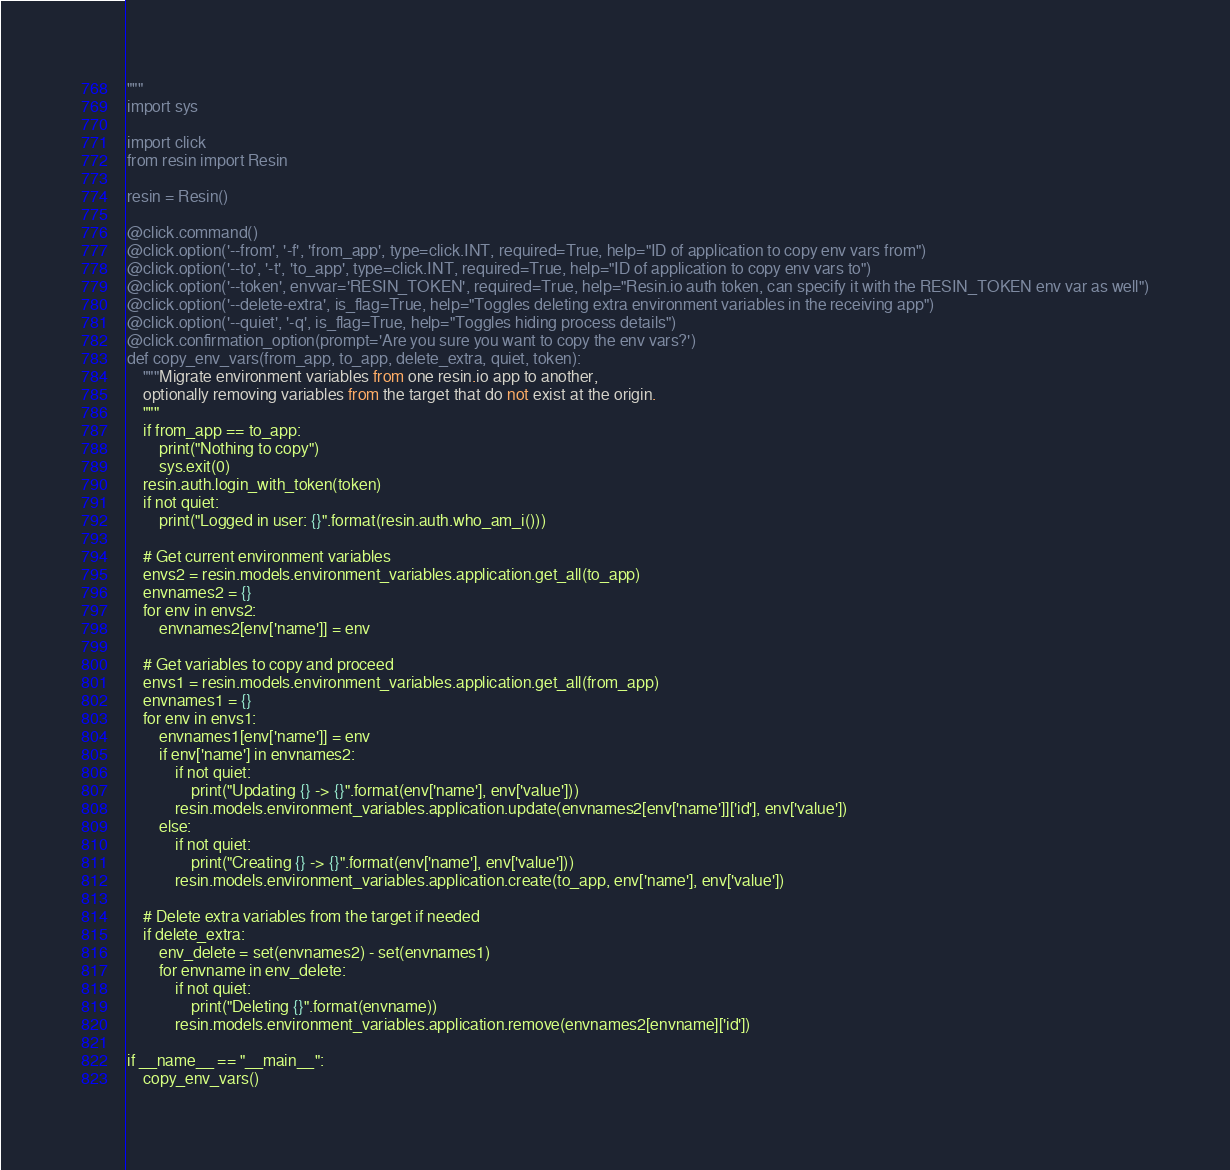<code> <loc_0><loc_0><loc_500><loc_500><_Python_>"""
import sys

import click
from resin import Resin

resin = Resin()

@click.command()
@click.option('--from', '-f', 'from_app', type=click.INT, required=True, help="ID of application to copy env vars from")
@click.option('--to', '-t', 'to_app', type=click.INT, required=True, help="ID of application to copy env vars to")
@click.option('--token', envvar='RESIN_TOKEN', required=True, help="Resin.io auth token, can specify it with the RESIN_TOKEN env var as well")
@click.option('--delete-extra', is_flag=True, help="Toggles deleting extra environment variables in the receiving app")
@click.option('--quiet', '-q', is_flag=True, help="Toggles hiding process details")
@click.confirmation_option(prompt='Are you sure you want to copy the env vars?')
def copy_env_vars(from_app, to_app, delete_extra, quiet, token):
    """Migrate environment variables from one resin.io app to another,
    optionally removing variables from the target that do not exist at the origin.
    """
    if from_app == to_app:
        print("Nothing to copy")
        sys.exit(0)
    resin.auth.login_with_token(token)
    if not quiet:
        print("Logged in user: {}".format(resin.auth.who_am_i()))

    # Get current environment variables
    envs2 = resin.models.environment_variables.application.get_all(to_app)
    envnames2 = {}
    for env in envs2:
        envnames2[env['name']] = env

    # Get variables to copy and proceed
    envs1 = resin.models.environment_variables.application.get_all(from_app)
    envnames1 = {}
    for env in envs1:
        envnames1[env['name']] = env
        if env['name'] in envnames2:
            if not quiet:
                print("Updating {} -> {}".format(env['name'], env['value']))
            resin.models.environment_variables.application.update(envnames2[env['name']]['id'], env['value'])
        else:
            if not quiet:
                print("Creating {} -> {}".format(env['name'], env['value']))
            resin.models.environment_variables.application.create(to_app, env['name'], env['value'])

    # Delete extra variables from the target if needed
    if delete_extra:
        env_delete = set(envnames2) - set(envnames1)
        for envname in env_delete:
            if not quiet:
                print("Deleting {}".format(envname))
            resin.models.environment_variables.application.remove(envnames2[envname]['id'])

if __name__ == "__main__":
    copy_env_vars()
</code> 